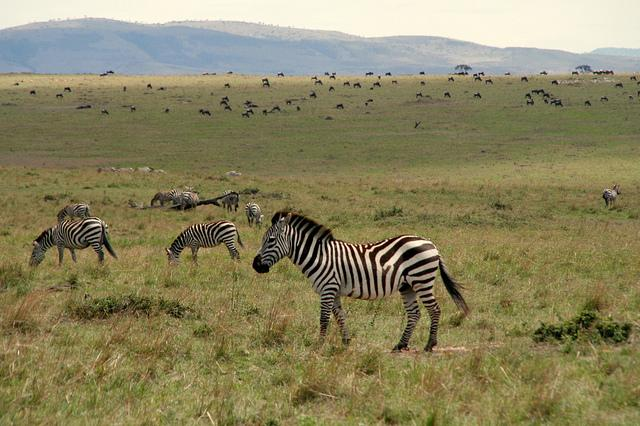What genus is this animal?

Choices:
A) equus
B) algae
C) plant
D) bovidae equus 